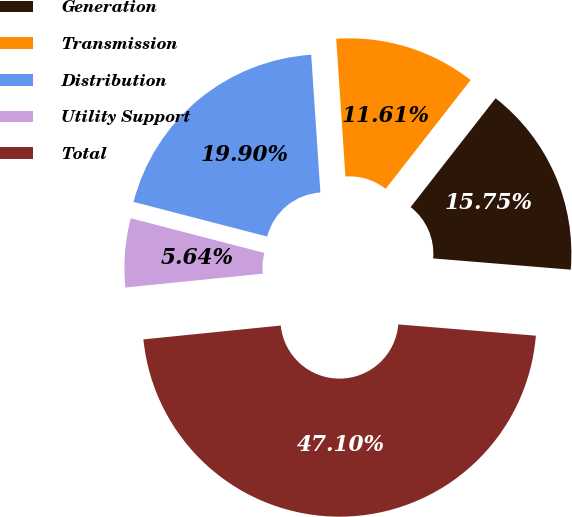Convert chart. <chart><loc_0><loc_0><loc_500><loc_500><pie_chart><fcel>Generation<fcel>Transmission<fcel>Distribution<fcel>Utility Support<fcel>Total<nl><fcel>15.75%<fcel>11.61%<fcel>19.9%<fcel>5.64%<fcel>47.1%<nl></chart> 